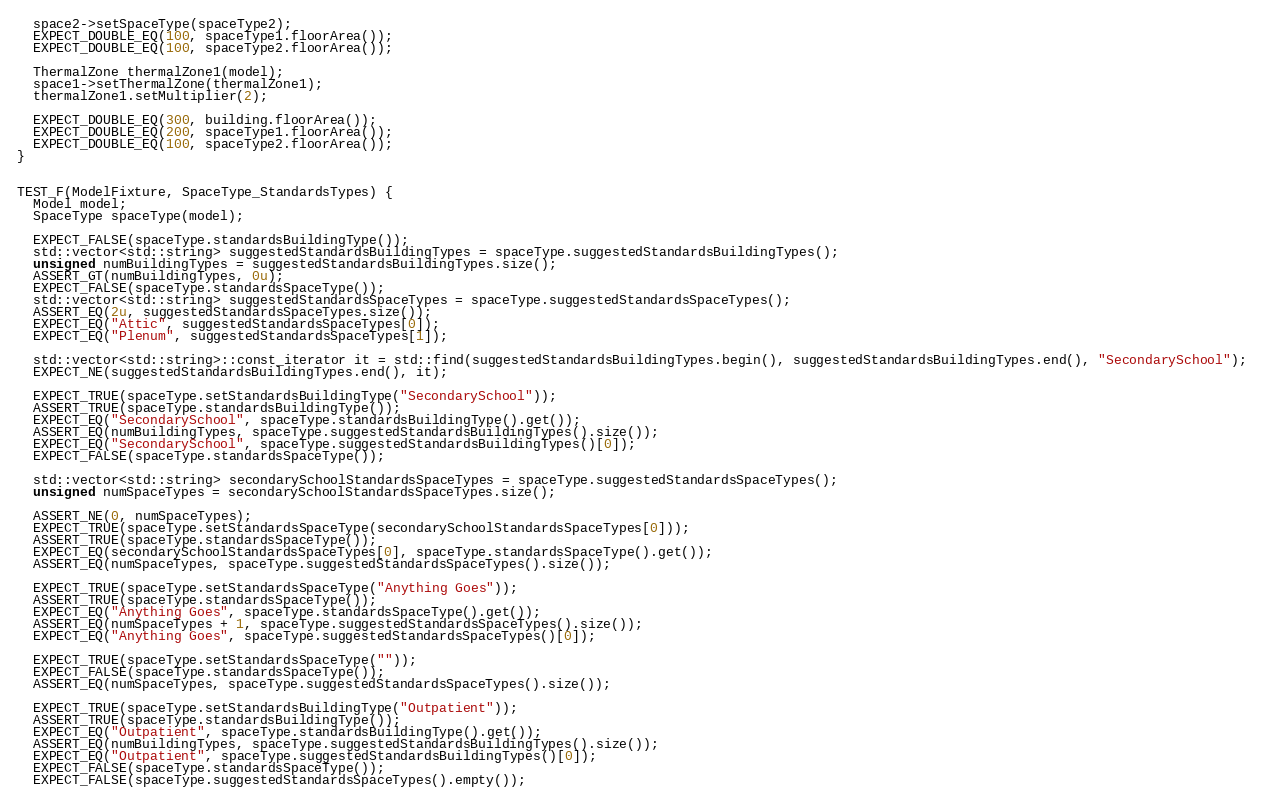Convert code to text. <code><loc_0><loc_0><loc_500><loc_500><_C++_>  space2->setSpaceType(spaceType2);
  EXPECT_DOUBLE_EQ(100, spaceType1.floorArea());
  EXPECT_DOUBLE_EQ(100, spaceType2.floorArea());

  ThermalZone thermalZone1(model);
  space1->setThermalZone(thermalZone1);
  thermalZone1.setMultiplier(2);

  EXPECT_DOUBLE_EQ(300, building.floorArea());
  EXPECT_DOUBLE_EQ(200, spaceType1.floorArea());
  EXPECT_DOUBLE_EQ(100, spaceType2.floorArea());
}


TEST_F(ModelFixture, SpaceType_StandardsTypes) {
  Model model;
  SpaceType spaceType(model);

  EXPECT_FALSE(spaceType.standardsBuildingType());
  std::vector<std::string> suggestedStandardsBuildingTypes = spaceType.suggestedStandardsBuildingTypes();
  unsigned numBuildingTypes = suggestedStandardsBuildingTypes.size();
  ASSERT_GT(numBuildingTypes, 0u);
  EXPECT_FALSE(spaceType.standardsSpaceType());
  std::vector<std::string> suggestedStandardsSpaceTypes = spaceType.suggestedStandardsSpaceTypes();
  ASSERT_EQ(2u, suggestedStandardsSpaceTypes.size());
  EXPECT_EQ("Attic", suggestedStandardsSpaceTypes[0]);
  EXPECT_EQ("Plenum", suggestedStandardsSpaceTypes[1]);

  std::vector<std::string>::const_iterator it = std::find(suggestedStandardsBuildingTypes.begin(), suggestedStandardsBuildingTypes.end(), "SecondarySchool");
  EXPECT_NE(suggestedStandardsBuildingTypes.end(), it);

  EXPECT_TRUE(spaceType.setStandardsBuildingType("SecondarySchool"));
  ASSERT_TRUE(spaceType.standardsBuildingType());
  EXPECT_EQ("SecondarySchool", spaceType.standardsBuildingType().get());
  ASSERT_EQ(numBuildingTypes, spaceType.suggestedStandardsBuildingTypes().size());
  EXPECT_EQ("SecondarySchool", spaceType.suggestedStandardsBuildingTypes()[0]);
  EXPECT_FALSE(spaceType.standardsSpaceType());

  std::vector<std::string> secondarySchoolStandardsSpaceTypes = spaceType.suggestedStandardsSpaceTypes();
  unsigned numSpaceTypes = secondarySchoolStandardsSpaceTypes.size();

  ASSERT_NE(0, numSpaceTypes);
  EXPECT_TRUE(spaceType.setStandardsSpaceType(secondarySchoolStandardsSpaceTypes[0]));
  ASSERT_TRUE(spaceType.standardsSpaceType());
  EXPECT_EQ(secondarySchoolStandardsSpaceTypes[0], spaceType.standardsSpaceType().get());
  ASSERT_EQ(numSpaceTypes, spaceType.suggestedStandardsSpaceTypes().size());

  EXPECT_TRUE(spaceType.setStandardsSpaceType("Anything Goes"));
  ASSERT_TRUE(spaceType.standardsSpaceType());
  EXPECT_EQ("Anything Goes", spaceType.standardsSpaceType().get());
  ASSERT_EQ(numSpaceTypes + 1, spaceType.suggestedStandardsSpaceTypes().size());
  EXPECT_EQ("Anything Goes", spaceType.suggestedStandardsSpaceTypes()[0]);

  EXPECT_TRUE(spaceType.setStandardsSpaceType(""));
  EXPECT_FALSE(spaceType.standardsSpaceType());
  ASSERT_EQ(numSpaceTypes, spaceType.suggestedStandardsSpaceTypes().size());

  EXPECT_TRUE(spaceType.setStandardsBuildingType("Outpatient"));
  ASSERT_TRUE(spaceType.standardsBuildingType());
  EXPECT_EQ("Outpatient", spaceType.standardsBuildingType().get());
  ASSERT_EQ(numBuildingTypes, spaceType.suggestedStandardsBuildingTypes().size());
  EXPECT_EQ("Outpatient", spaceType.suggestedStandardsBuildingTypes()[0]);
  EXPECT_FALSE(spaceType.standardsSpaceType());
  EXPECT_FALSE(spaceType.suggestedStandardsSpaceTypes().empty());
</code> 